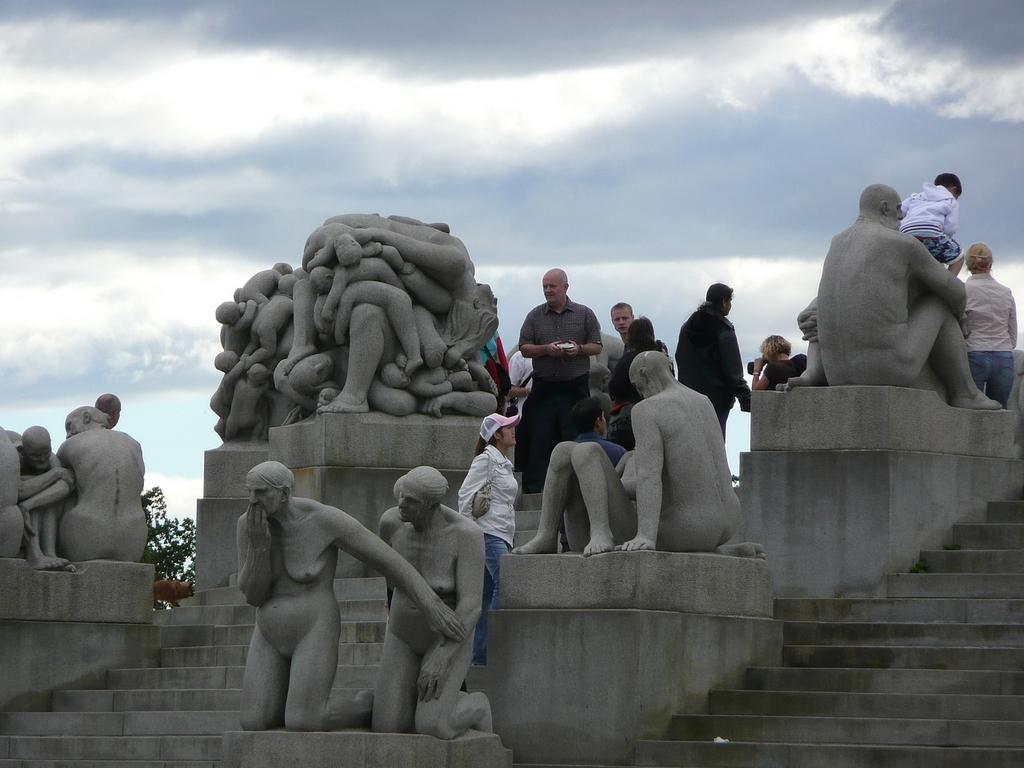What can be seen in the image that represents artistic creations? There are statues in the image. What architectural feature is present in the image? There are stairs in the image. Where is the boy located in the image? The boy is sitting on the right side of the image. What type of plant is on the left side of the image? There is a tree on the left side of the image. What is the condition of the sky in the image? The sky is clear in the image. Can you tell me how many tigers are climbing the tree on the left side of the image? There are no tigers present in the image; it features a tree without any animals. What color is the boy's wrist in the image? The image does not provide information about the color of the boy's wrist, as it focuses on the overall scene and not specific body parts. 